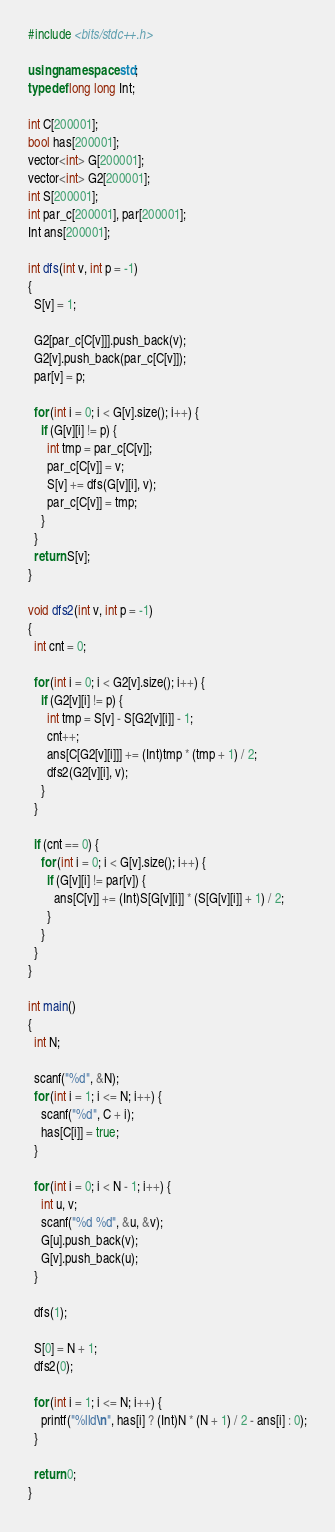Convert code to text. <code><loc_0><loc_0><loc_500><loc_500><_C++_>#include <bits/stdc++.h>

using namespace std;
typedef long long Int;

int C[200001];
bool has[200001];
vector<int> G[200001];
vector<int> G2[200001];
int S[200001];
int par_c[200001], par[200001];
Int ans[200001];

int dfs(int v, int p = -1)
{
  S[v] = 1;
  
  G2[par_c[C[v]]].push_back(v);
  G2[v].push_back(par_c[C[v]]);
  par[v] = p;
  
  for (int i = 0; i < G[v].size(); i++) {
    if (G[v][i] != p) {
      int tmp = par_c[C[v]];
      par_c[C[v]] = v;
      S[v] += dfs(G[v][i], v);
      par_c[C[v]] = tmp;
    }
  }
  return S[v];
}

void dfs2(int v, int p = -1)
{
  int cnt = 0;
  
  for (int i = 0; i < G2[v].size(); i++) {
    if (G2[v][i] != p) {
      int tmp = S[v] - S[G2[v][i]] - 1;
      cnt++;
      ans[C[G2[v][i]]] += (Int)tmp * (tmp + 1) / 2;
      dfs2(G2[v][i], v);
    }
  }
  
  if (cnt == 0) {
    for (int i = 0; i < G[v].size(); i++) {
      if (G[v][i] != par[v]) {
      	ans[C[v]] += (Int)S[G[v][i]] * (S[G[v][i]] + 1) / 2;
      }
    }
  }
}

int main()
{
  int N;
  
  scanf("%d", &N);
  for (int i = 1; i <= N; i++) {
    scanf("%d", C + i);
    has[C[i]] = true;
  }
  
  for (int i = 0; i < N - 1; i++) {
    int u, v;
    scanf("%d %d", &u, &v);
    G[u].push_back(v);
    G[v].push_back(u);
  }
  
  dfs(1);
  
  S[0] = N + 1;
  dfs2(0);
  
  for (int i = 1; i <= N; i++) {
    printf("%lld\n", has[i] ? (Int)N * (N + 1) / 2 - ans[i] : 0);
  }
  
  return 0;
}</code> 